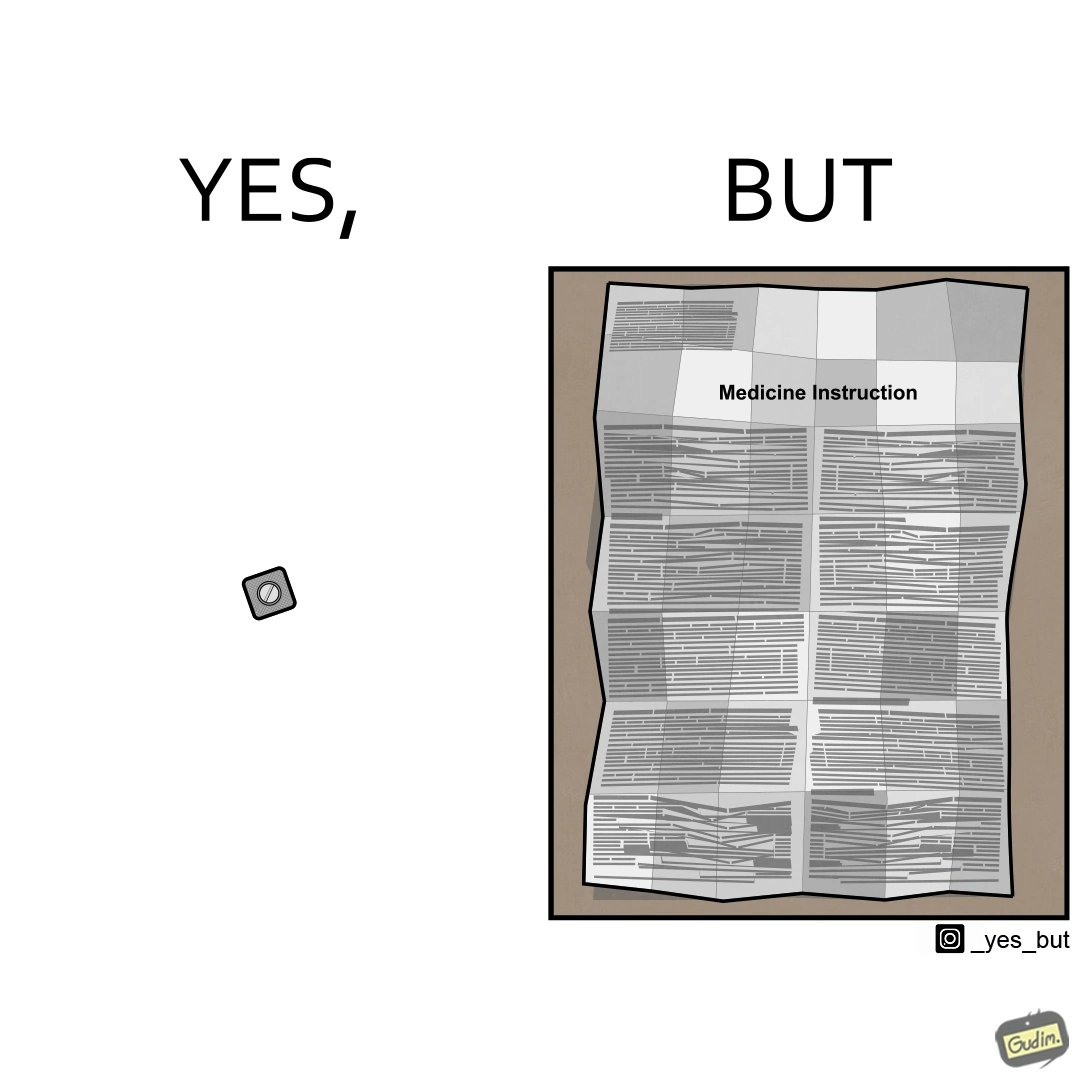What makes this image funny or satirical? the irony in this image is a small thing like a medicine very often has instructions and a manual that is extremely long 